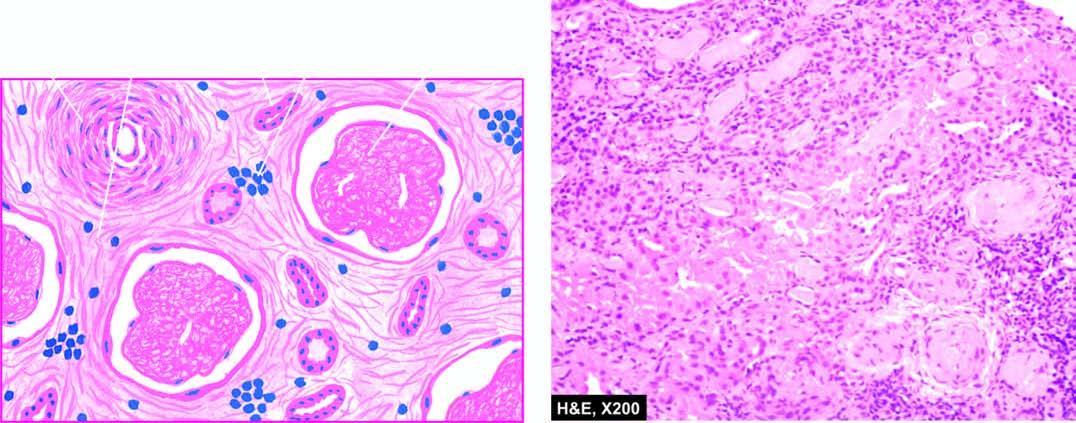re the predominant histologic changes acellular and completely hyalinised?
Answer the question using a single word or phrase. No 